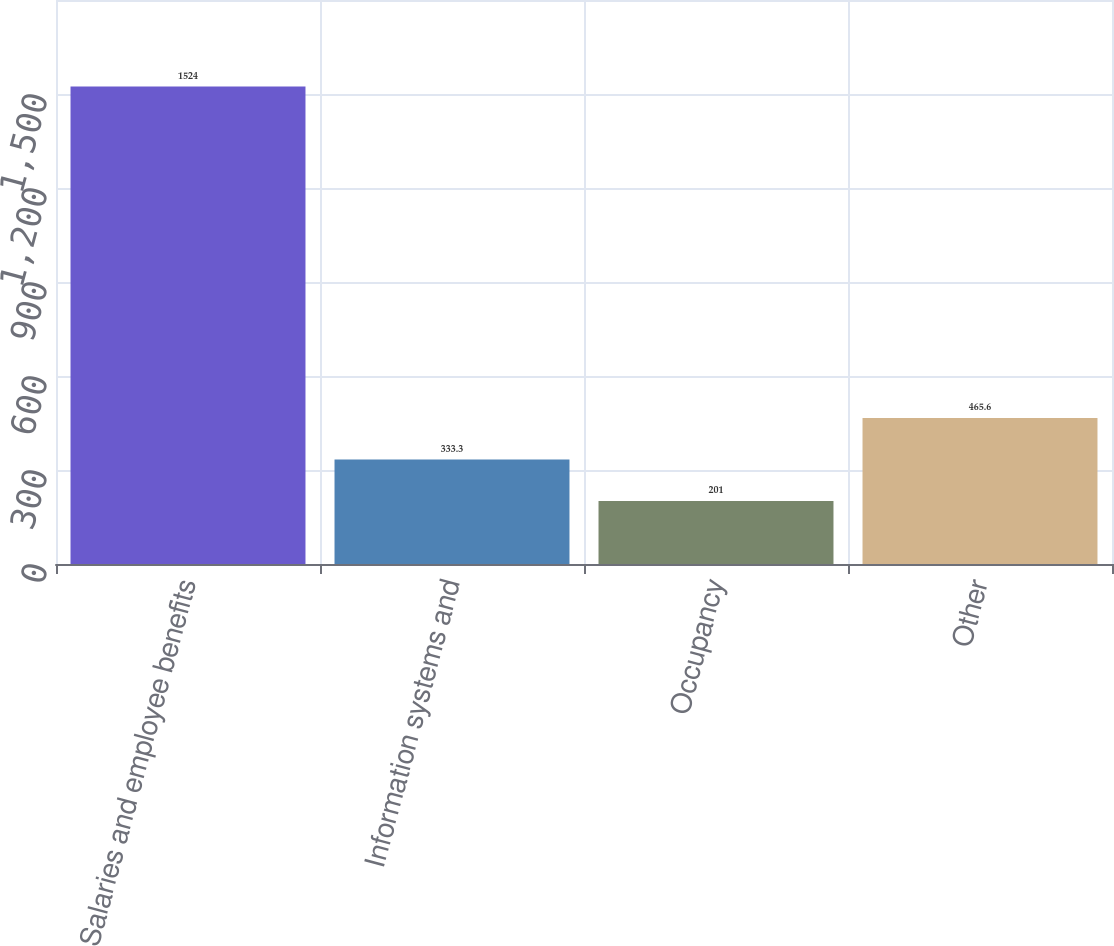Convert chart. <chart><loc_0><loc_0><loc_500><loc_500><bar_chart><fcel>Salaries and employee benefits<fcel>Information systems and<fcel>Occupancy<fcel>Other<nl><fcel>1524<fcel>333.3<fcel>201<fcel>465.6<nl></chart> 